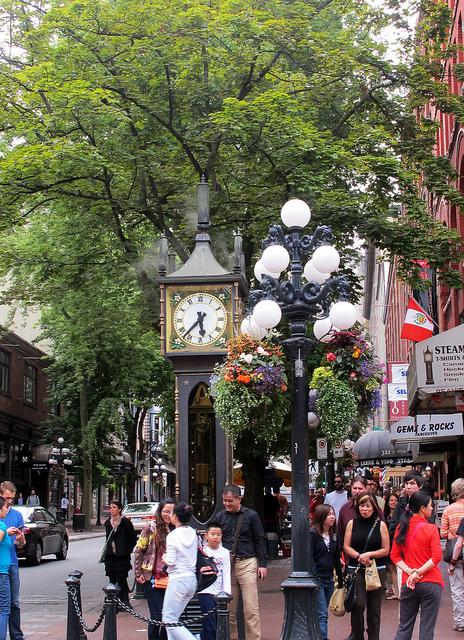What is coming out of the clock?

Choices:
A) vapor
B) water
C) steam
D) smoke steam 